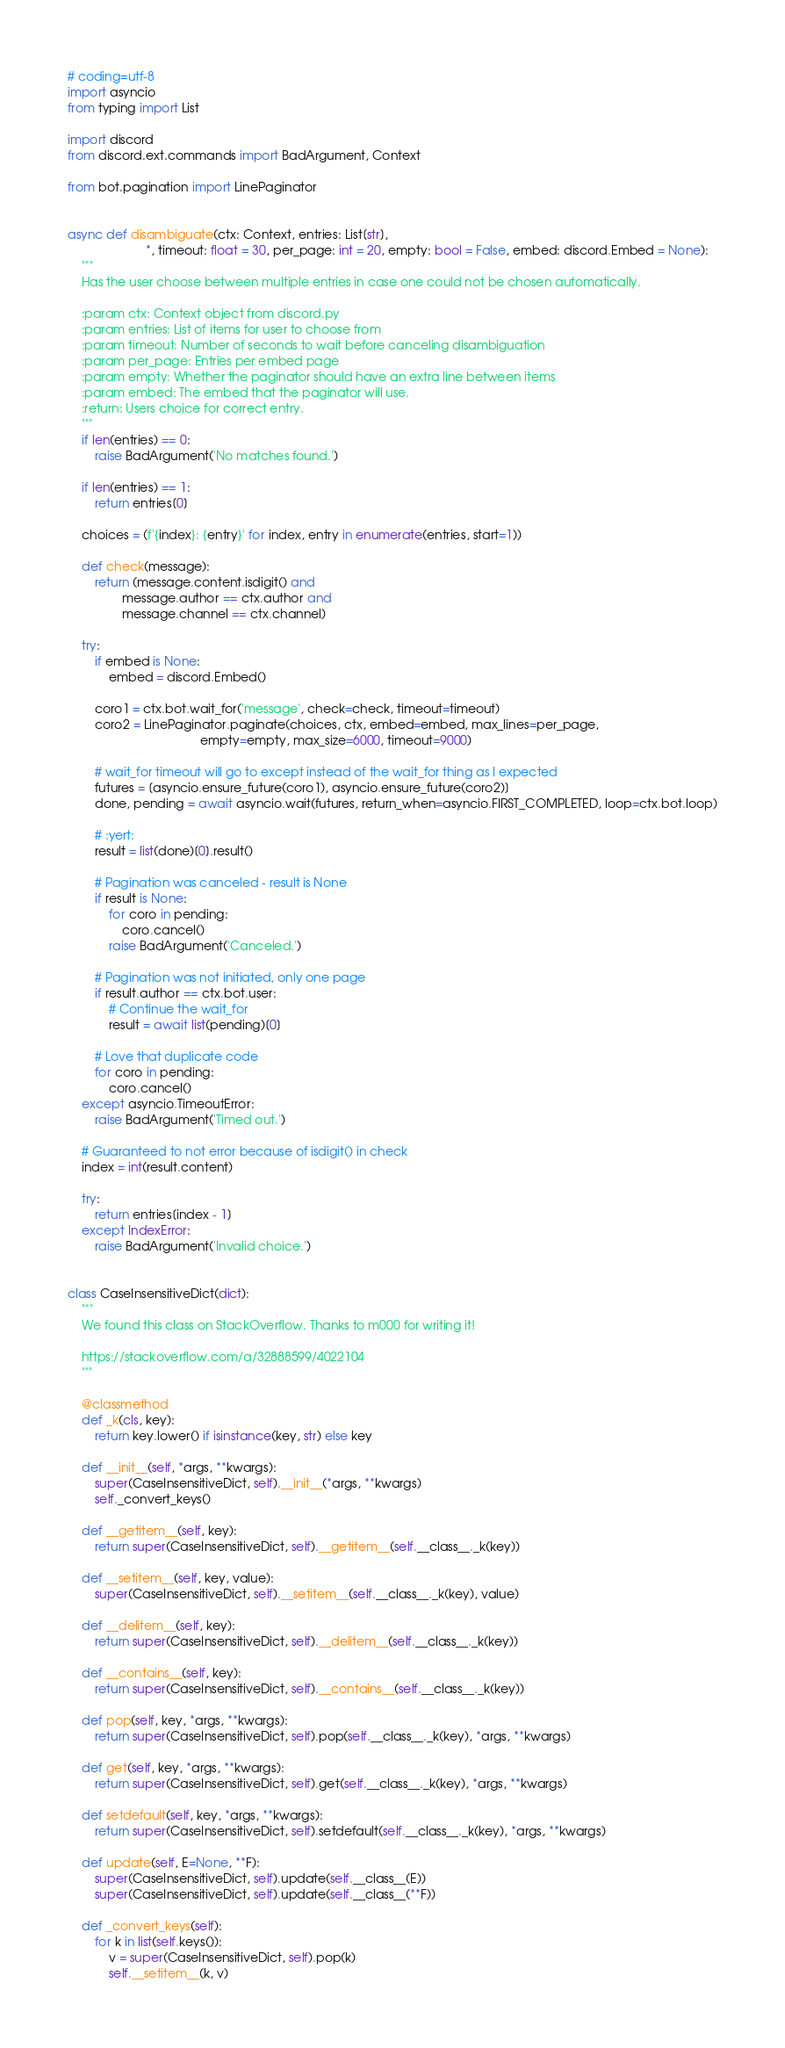Convert code to text. <code><loc_0><loc_0><loc_500><loc_500><_Python_># coding=utf-8
import asyncio
from typing import List

import discord
from discord.ext.commands import BadArgument, Context

from bot.pagination import LinePaginator


async def disambiguate(ctx: Context, entries: List[str],
                       *, timeout: float = 30, per_page: int = 20, empty: bool = False, embed: discord.Embed = None):
    """
    Has the user choose between multiple entries in case one could not be chosen automatically.

    :param ctx: Context object from discord.py
    :param entries: List of items for user to choose from
    :param timeout: Number of seconds to wait before canceling disambiguation
    :param per_page: Entries per embed page
    :param empty: Whether the paginator should have an extra line between items
    :param embed: The embed that the paginator will use.
    :return: Users choice for correct entry.
    """
    if len(entries) == 0:
        raise BadArgument('No matches found.')

    if len(entries) == 1:
        return entries[0]

    choices = (f'{index}: {entry}' for index, entry in enumerate(entries, start=1))

    def check(message):
        return (message.content.isdigit() and
                message.author == ctx.author and
                message.channel == ctx.channel)

    try:
        if embed is None:
            embed = discord.Embed()

        coro1 = ctx.bot.wait_for('message', check=check, timeout=timeout)
        coro2 = LinePaginator.paginate(choices, ctx, embed=embed, max_lines=per_page,
                                       empty=empty, max_size=6000, timeout=9000)

        # wait_for timeout will go to except instead of the wait_for thing as I expected
        futures = [asyncio.ensure_future(coro1), asyncio.ensure_future(coro2)]
        done, pending = await asyncio.wait(futures, return_when=asyncio.FIRST_COMPLETED, loop=ctx.bot.loop)

        # :yert:
        result = list(done)[0].result()

        # Pagination was canceled - result is None
        if result is None:
            for coro in pending:
                coro.cancel()
            raise BadArgument('Canceled.')

        # Pagination was not initiated, only one page
        if result.author == ctx.bot.user:
            # Continue the wait_for
            result = await list(pending)[0]

        # Love that duplicate code
        for coro in pending:
            coro.cancel()
    except asyncio.TimeoutError:
        raise BadArgument('Timed out.')

    # Guaranteed to not error because of isdigit() in check
    index = int(result.content)

    try:
        return entries[index - 1]
    except IndexError:
        raise BadArgument('Invalid choice.')


class CaseInsensitiveDict(dict):
    """
    We found this class on StackOverflow. Thanks to m000 for writing it!

    https://stackoverflow.com/a/32888599/4022104
    """

    @classmethod
    def _k(cls, key):
        return key.lower() if isinstance(key, str) else key

    def __init__(self, *args, **kwargs):
        super(CaseInsensitiveDict, self).__init__(*args, **kwargs)
        self._convert_keys()

    def __getitem__(self, key):
        return super(CaseInsensitiveDict, self).__getitem__(self.__class__._k(key))

    def __setitem__(self, key, value):
        super(CaseInsensitiveDict, self).__setitem__(self.__class__._k(key), value)

    def __delitem__(self, key):
        return super(CaseInsensitiveDict, self).__delitem__(self.__class__._k(key))

    def __contains__(self, key):
        return super(CaseInsensitiveDict, self).__contains__(self.__class__._k(key))

    def pop(self, key, *args, **kwargs):
        return super(CaseInsensitiveDict, self).pop(self.__class__._k(key), *args, **kwargs)

    def get(self, key, *args, **kwargs):
        return super(CaseInsensitiveDict, self).get(self.__class__._k(key), *args, **kwargs)

    def setdefault(self, key, *args, **kwargs):
        return super(CaseInsensitiveDict, self).setdefault(self.__class__._k(key), *args, **kwargs)

    def update(self, E=None, **F):
        super(CaseInsensitiveDict, self).update(self.__class__(E))
        super(CaseInsensitiveDict, self).update(self.__class__(**F))

    def _convert_keys(self):
        for k in list(self.keys()):
            v = super(CaseInsensitiveDict, self).pop(k)
            self.__setitem__(k, v)
</code> 